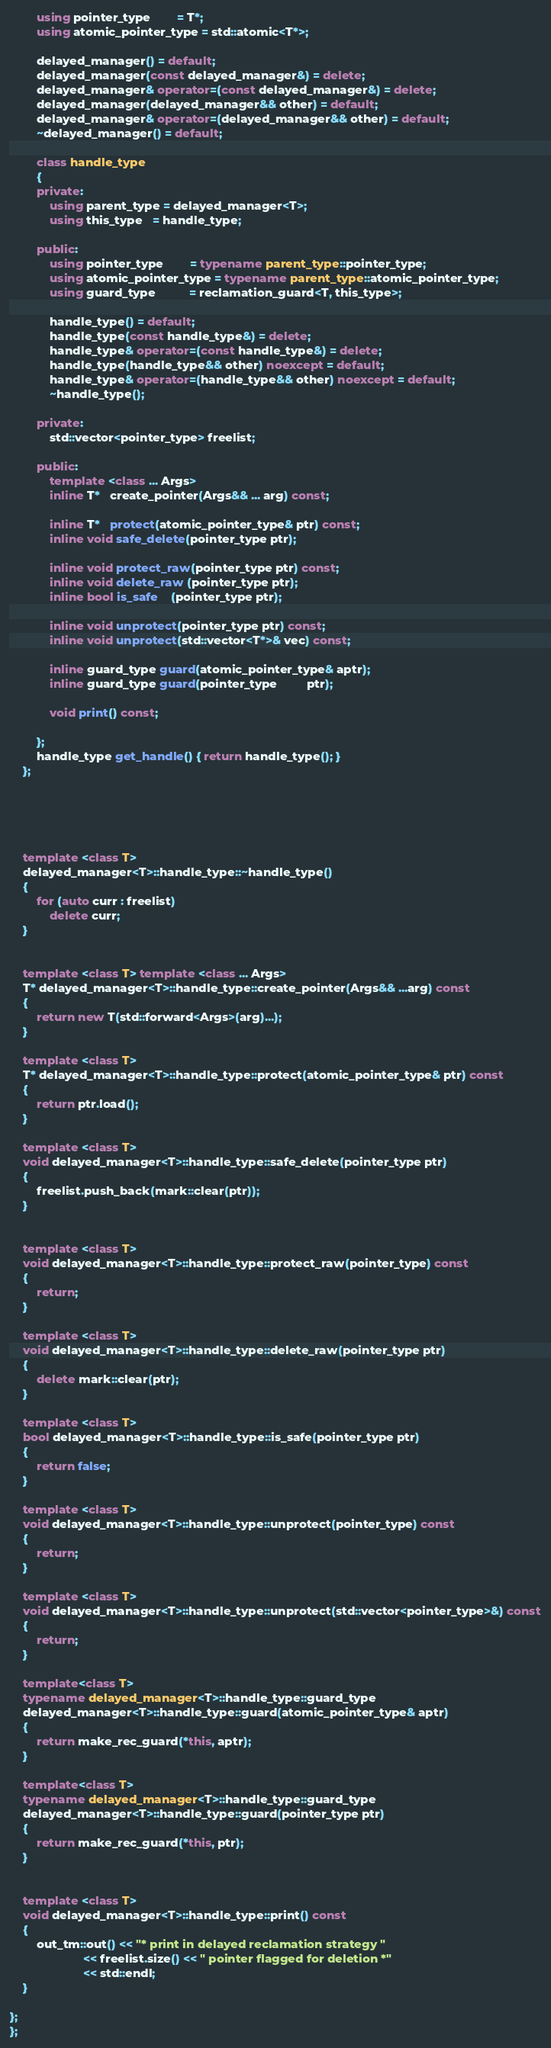<code> <loc_0><loc_0><loc_500><loc_500><_C++_>        using pointer_type        = T*;
        using atomic_pointer_type = std::atomic<T*>;

        delayed_manager() = default;
        delayed_manager(const delayed_manager&) = delete;
        delayed_manager& operator=(const delayed_manager&) = delete;
        delayed_manager(delayed_manager&& other) = default;
        delayed_manager& operator=(delayed_manager&& other) = default;
        ~delayed_manager() = default;

        class handle_type
        {
        private:
            using parent_type = delayed_manager<T>;
            using this_type   = handle_type;

        public:
            using pointer_type        = typename parent_type::pointer_type;
            using atomic_pointer_type = typename parent_type::atomic_pointer_type;
            using guard_type          = reclamation_guard<T, this_type>;

            handle_type() = default;
            handle_type(const handle_type&) = delete;
            handle_type& operator=(const handle_type&) = delete;
            handle_type(handle_type&& other) noexcept = default;
            handle_type& operator=(handle_type&& other) noexcept = default;
            ~handle_type();

        private:
            std::vector<pointer_type> freelist;

        public:
            template <class ... Args>
            inline T*   create_pointer(Args&& ... arg) const;

            inline T*   protect(atomic_pointer_type& ptr) const;
            inline void safe_delete(pointer_type ptr);

            inline void protect_raw(pointer_type ptr) const;
            inline void delete_raw (pointer_type ptr);
            inline bool is_safe    (pointer_type ptr);

            inline void unprotect(pointer_type ptr) const;
            inline void unprotect(std::vector<T*>& vec) const;

            inline guard_type guard(atomic_pointer_type& aptr);
            inline guard_type guard(pointer_type         ptr);

            void print() const;

        };
        handle_type get_handle() { return handle_type(); }
    };





    template <class T>
    delayed_manager<T>::handle_type::~handle_type()
    {
        for (auto curr : freelist)
            delete curr;
    }


    template <class T> template <class ... Args>
    T* delayed_manager<T>::handle_type::create_pointer(Args&& ...arg) const
    {
        return new T(std::forward<Args>(arg)...);
    }

    template <class T>
    T* delayed_manager<T>::handle_type::protect(atomic_pointer_type& ptr) const
    {
        return ptr.load();
    }

    template <class T>
    void delayed_manager<T>::handle_type::safe_delete(pointer_type ptr)
    {
        freelist.push_back(mark::clear(ptr));
    }


    template <class T>
    void delayed_manager<T>::handle_type::protect_raw(pointer_type) const
    {
        return;
    }

    template <class T>
    void delayed_manager<T>::handle_type::delete_raw(pointer_type ptr)
    {
        delete mark::clear(ptr);
    }

    template <class T>
    bool delayed_manager<T>::handle_type::is_safe(pointer_type ptr)
    {
        return false;
    }

    template <class T>
    void delayed_manager<T>::handle_type::unprotect(pointer_type) const
    {
        return;
    }

    template <class T>
    void delayed_manager<T>::handle_type::unprotect(std::vector<pointer_type>&) const
    {
        return;
    }

    template<class T>
    typename delayed_manager<T>::handle_type::guard_type
    delayed_manager<T>::handle_type::guard(atomic_pointer_type& aptr)
    {
        return make_rec_guard(*this, aptr);
    }

    template<class T>
    typename delayed_manager<T>::handle_type::guard_type
    delayed_manager<T>::handle_type::guard(pointer_type ptr)
    {
        return make_rec_guard(*this, ptr);
    }


    template <class T>
    void delayed_manager<T>::handle_type::print() const
    {
        out_tm::out() << "* print in delayed reclamation strategy "
                      << freelist.size() << " pointer flagged for deletion *"
                      << std::endl;
    }

};
};
</code> 